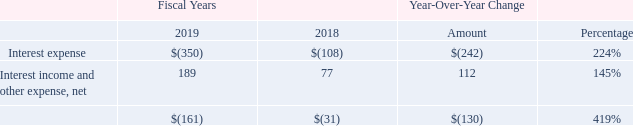Interest Expense and Interest Income and Other Expense, net
The table below sets forth the changes in interest expense and interest income and other expense, net, for the fiscal year ended December 29, 2019, as compared to fiscal year ended December 30, 2018 (in thousands, except percentage data):
The $242,000 increase in interest expense was attributable to higher line of credit balance in 2019 compared to 2018. The $112,000 increase in interest income and other expenses was attributable to increase in interest income from money market account with Heritage Bank.
What are the respective interest expense in 2018 and 2019?
Answer scale should be: thousand. 108, 350. What are the respective net values of interest income and other expenses in 2018 and 2019?
Answer scale should be: thousand. 77, 189. What is the increase in interest expense between 2018 and 2019? $242,000. What is the average interest expense in 2018 and 2019?
Answer scale should be: thousand. (108 + 350)/2 
Answer: 229. What is the average net interest income and other expense in 2018 and 2019?
Answer scale should be: thousand. (77 + 189)/2 
Answer: 133. What is the average total interest expense and interest income and other expense, net, in 2018 and 2019?
Answer scale should be: thousand. -(31 + 161)/2 
Answer: -96. 